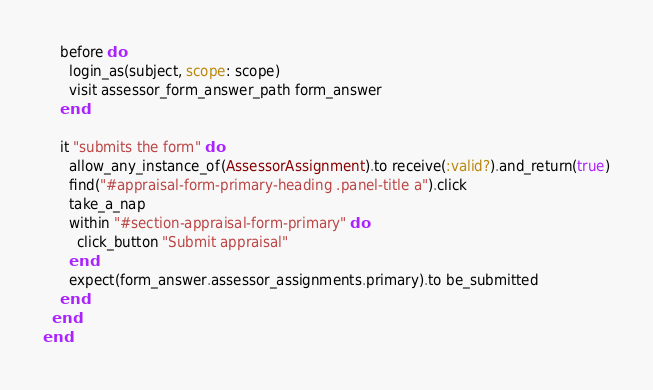Convert code to text. <code><loc_0><loc_0><loc_500><loc_500><_Ruby_>
    before do
      login_as(subject, scope: scope)
      visit assessor_form_answer_path form_answer
    end

    it "submits the form" do
      allow_any_instance_of(AssessorAssignment).to receive(:valid?).and_return(true)
      find("#appraisal-form-primary-heading .panel-title a").click
      take_a_nap
      within "#section-appraisal-form-primary" do
        click_button "Submit appraisal"
      end
      expect(form_answer.assessor_assignments.primary).to be_submitted
    end
  end
end
</code> 